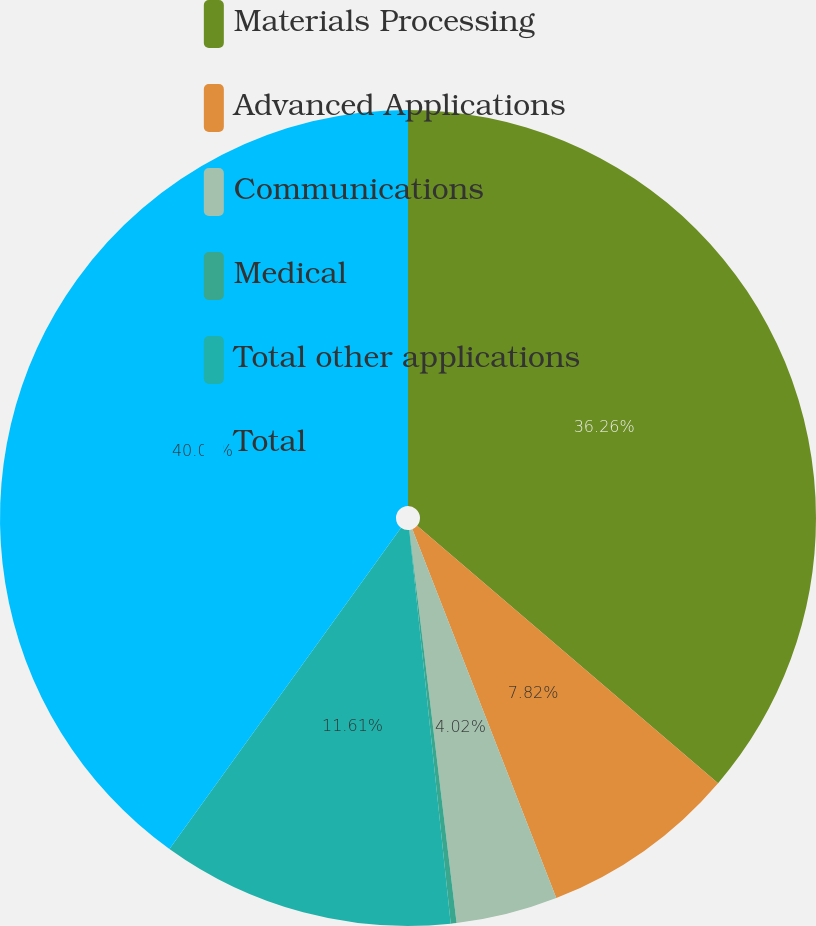Convert chart to OTSL. <chart><loc_0><loc_0><loc_500><loc_500><pie_chart><fcel>Materials Processing<fcel>Advanced Applications<fcel>Communications<fcel>Medical<fcel>Total other applications<fcel>Total<nl><fcel>36.26%<fcel>7.82%<fcel>4.02%<fcel>0.23%<fcel>11.61%<fcel>40.06%<nl></chart> 